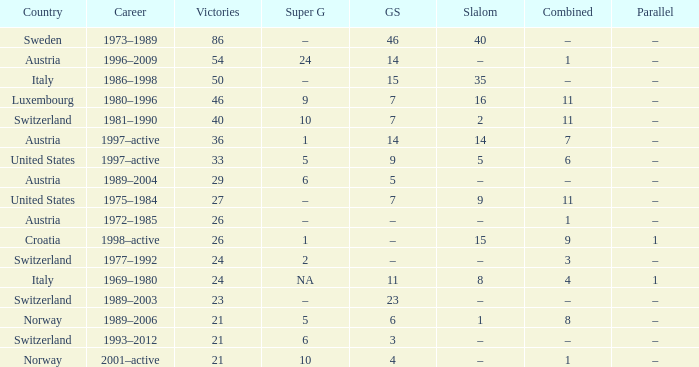What Country has a Career of 1989–2004? Austria. 